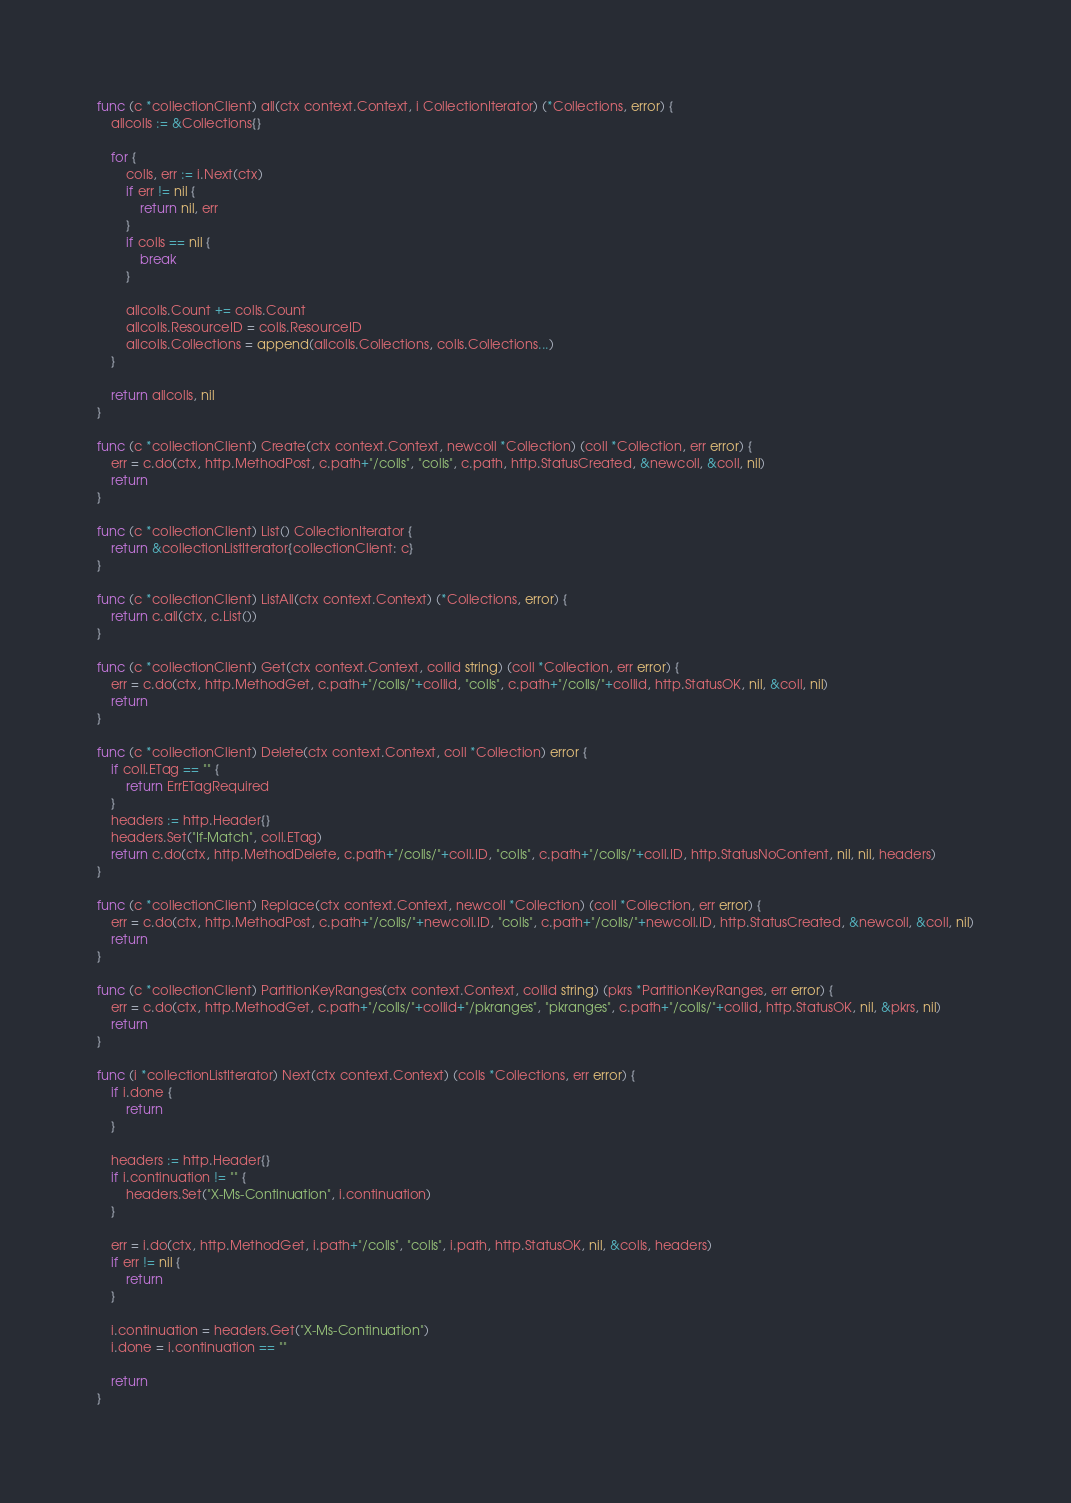Convert code to text. <code><loc_0><loc_0><loc_500><loc_500><_Go_>func (c *collectionClient) all(ctx context.Context, i CollectionIterator) (*Collections, error) {
	allcolls := &Collections{}

	for {
		colls, err := i.Next(ctx)
		if err != nil {
			return nil, err
		}
		if colls == nil {
			break
		}

		allcolls.Count += colls.Count
		allcolls.ResourceID = colls.ResourceID
		allcolls.Collections = append(allcolls.Collections, colls.Collections...)
	}

	return allcolls, nil
}

func (c *collectionClient) Create(ctx context.Context, newcoll *Collection) (coll *Collection, err error) {
	err = c.do(ctx, http.MethodPost, c.path+"/colls", "colls", c.path, http.StatusCreated, &newcoll, &coll, nil)
	return
}

func (c *collectionClient) List() CollectionIterator {
	return &collectionListIterator{collectionClient: c}
}

func (c *collectionClient) ListAll(ctx context.Context) (*Collections, error) {
	return c.all(ctx, c.List())
}

func (c *collectionClient) Get(ctx context.Context, collid string) (coll *Collection, err error) {
	err = c.do(ctx, http.MethodGet, c.path+"/colls/"+collid, "colls", c.path+"/colls/"+collid, http.StatusOK, nil, &coll, nil)
	return
}

func (c *collectionClient) Delete(ctx context.Context, coll *Collection) error {
	if coll.ETag == "" {
		return ErrETagRequired
	}
	headers := http.Header{}
	headers.Set("If-Match", coll.ETag)
	return c.do(ctx, http.MethodDelete, c.path+"/colls/"+coll.ID, "colls", c.path+"/colls/"+coll.ID, http.StatusNoContent, nil, nil, headers)
}

func (c *collectionClient) Replace(ctx context.Context, newcoll *Collection) (coll *Collection, err error) {
	err = c.do(ctx, http.MethodPost, c.path+"/colls/"+newcoll.ID, "colls", c.path+"/colls/"+newcoll.ID, http.StatusCreated, &newcoll, &coll, nil)
	return
}

func (c *collectionClient) PartitionKeyRanges(ctx context.Context, collid string) (pkrs *PartitionKeyRanges, err error) {
	err = c.do(ctx, http.MethodGet, c.path+"/colls/"+collid+"/pkranges", "pkranges", c.path+"/colls/"+collid, http.StatusOK, nil, &pkrs, nil)
	return
}

func (i *collectionListIterator) Next(ctx context.Context) (colls *Collections, err error) {
	if i.done {
		return
	}

	headers := http.Header{}
	if i.continuation != "" {
		headers.Set("X-Ms-Continuation", i.continuation)
	}

	err = i.do(ctx, http.MethodGet, i.path+"/colls", "colls", i.path, http.StatusOK, nil, &colls, headers)
	if err != nil {
		return
	}

	i.continuation = headers.Get("X-Ms-Continuation")
	i.done = i.continuation == ""

	return
}
</code> 